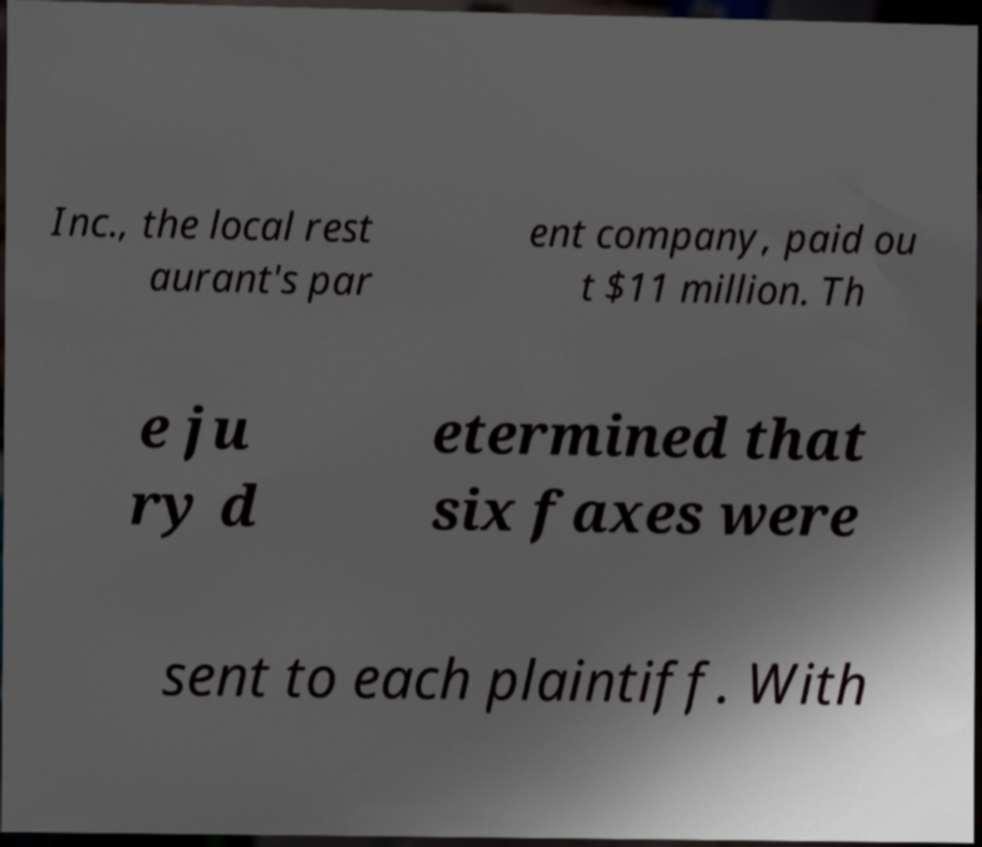For documentation purposes, I need the text within this image transcribed. Could you provide that? Inc., the local rest aurant's par ent company, paid ou t $11 million. Th e ju ry d etermined that six faxes were sent to each plaintiff. With 